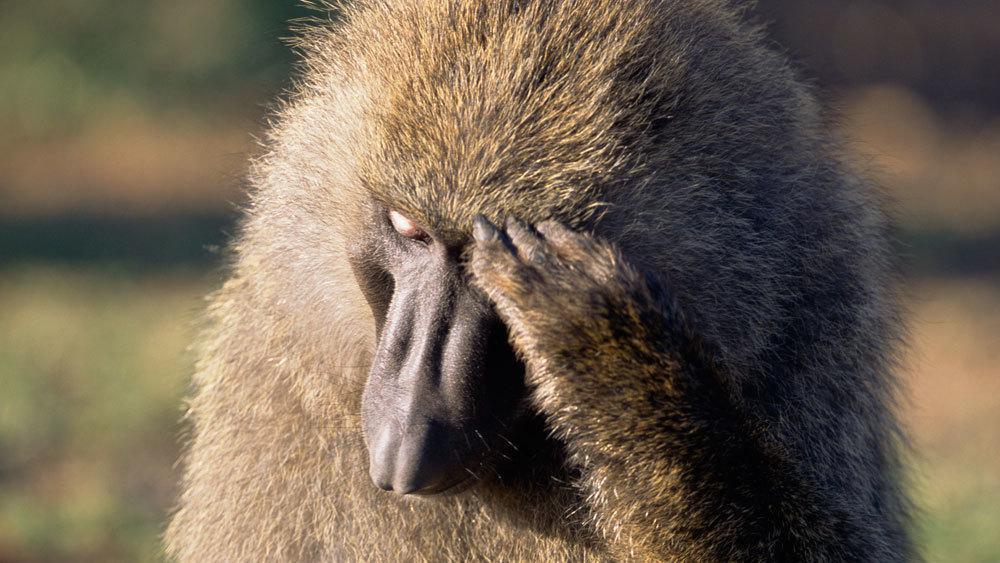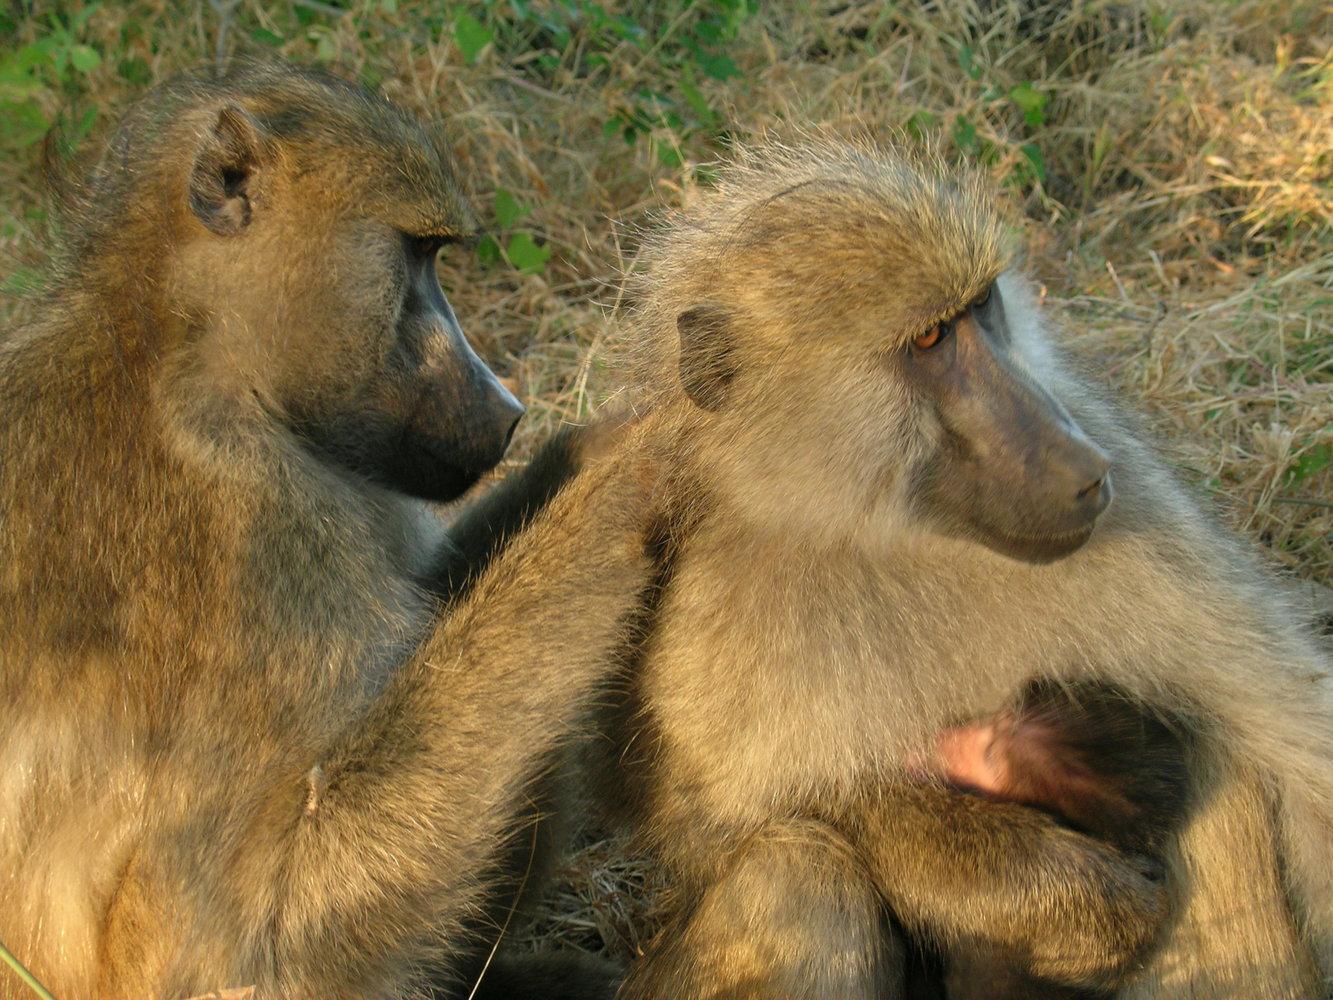The first image is the image on the left, the second image is the image on the right. Considering the images on both sides, is "The right image contains at least two baboons." valid? Answer yes or no. Yes. The first image is the image on the left, the second image is the image on the right. Evaluate the accuracy of this statement regarding the images: "There are no more than three monkeys total per pair of images.". Is it true? Answer yes or no. No. The first image is the image on the left, the second image is the image on the right. Evaluate the accuracy of this statement regarding the images: "A pink-faced baby baboo is held to the chest of its rightward-turned mother in one image.". Is it true? Answer yes or no. Yes. 